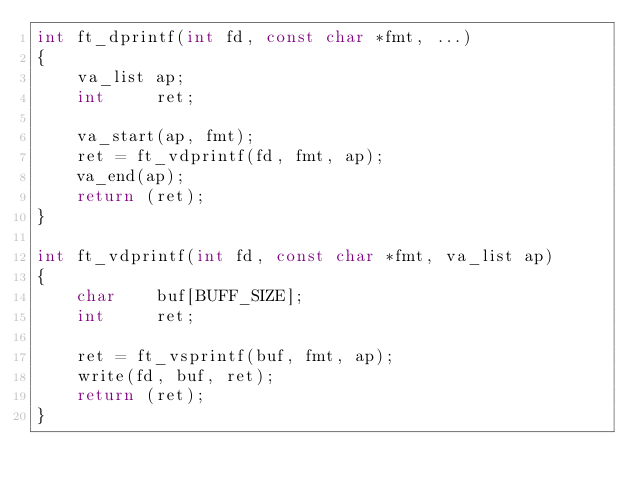Convert code to text. <code><loc_0><loc_0><loc_500><loc_500><_C_>int	ft_dprintf(int fd, const char *fmt, ...)
{
	va_list	ap;
	int		ret;

	va_start(ap, fmt);
	ret = ft_vdprintf(fd, fmt, ap);
	va_end(ap);
	return (ret);
}

int	ft_vdprintf(int fd, const char *fmt, va_list ap)
{
	char	buf[BUFF_SIZE];
	int		ret;

	ret = ft_vsprintf(buf, fmt, ap);
	write(fd, buf, ret);
	return (ret);
}
</code> 